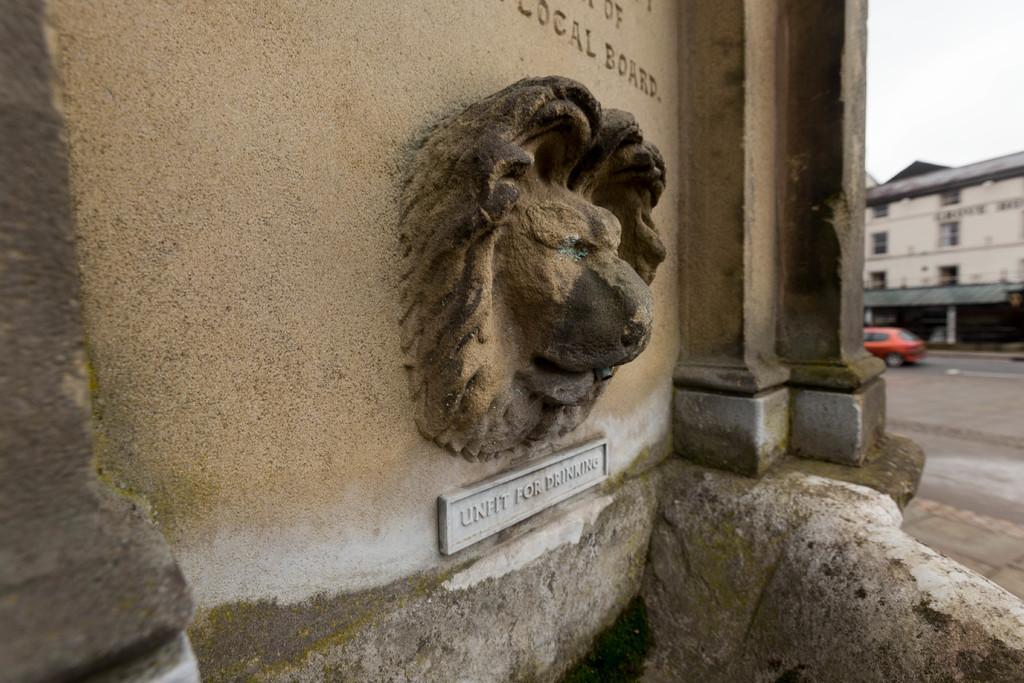Describe this image in one or two sentences. In this image I can see a sculpture and something written on the wall. On the right side I can see a building, vehicle on the road and the sky. 